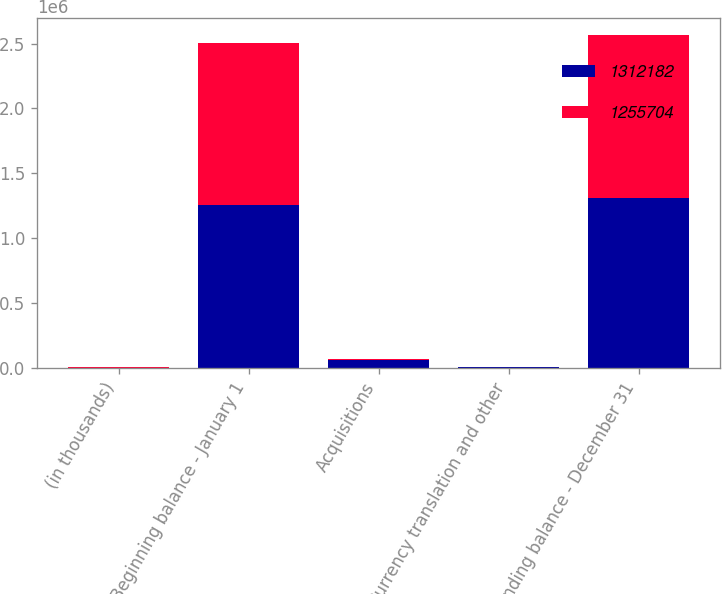Convert chart to OTSL. <chart><loc_0><loc_0><loc_500><loc_500><stacked_bar_chart><ecel><fcel>(in thousands)<fcel>Beginning balance - January 1<fcel>Acquisitions<fcel>Currency translation and other<fcel>Ending balance - December 31<nl><fcel>1.31218e+06<fcel>2014<fcel>1.2557e+06<fcel>61103<fcel>4625<fcel>1.31218e+06<nl><fcel>1.2557e+06<fcel>2013<fcel>1.25125e+06<fcel>5936<fcel>1479<fcel>1.2557e+06<nl></chart> 